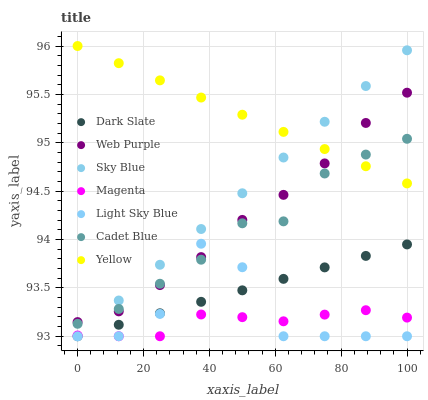Does Magenta have the minimum area under the curve?
Answer yes or no. Yes. Does Yellow have the maximum area under the curve?
Answer yes or no. Yes. Does Dark Slate have the minimum area under the curve?
Answer yes or no. No. Does Dark Slate have the maximum area under the curve?
Answer yes or no. No. Is Yellow the smoothest?
Answer yes or no. Yes. Is Light Sky Blue the roughest?
Answer yes or no. Yes. Is Dark Slate the smoothest?
Answer yes or no. No. Is Dark Slate the roughest?
Answer yes or no. No. Does Dark Slate have the lowest value?
Answer yes or no. Yes. Does Yellow have the lowest value?
Answer yes or no. No. Does Yellow have the highest value?
Answer yes or no. Yes. Does Dark Slate have the highest value?
Answer yes or no. No. Is Magenta less than Yellow?
Answer yes or no. Yes. Is Yellow greater than Dark Slate?
Answer yes or no. Yes. Does Magenta intersect Sky Blue?
Answer yes or no. Yes. Is Magenta less than Sky Blue?
Answer yes or no. No. Is Magenta greater than Sky Blue?
Answer yes or no. No. Does Magenta intersect Yellow?
Answer yes or no. No. 